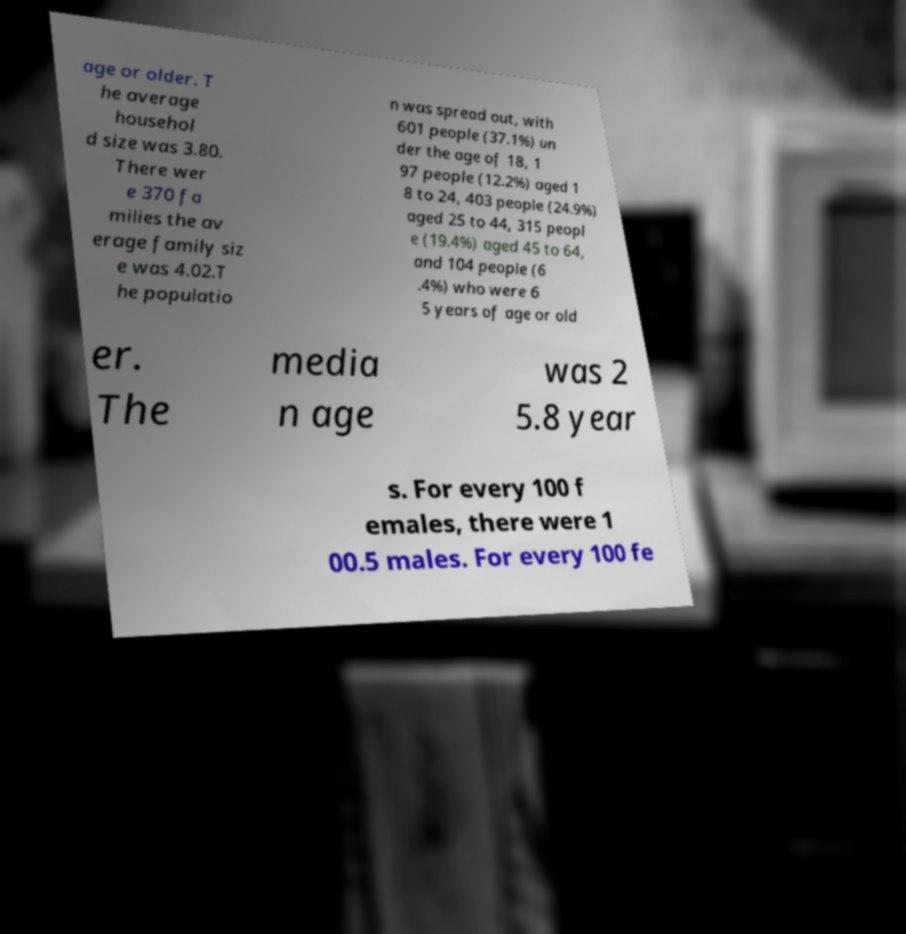Could you assist in decoding the text presented in this image and type it out clearly? age or older. T he average househol d size was 3.80. There wer e 370 fa milies the av erage family siz e was 4.02.T he populatio n was spread out, with 601 people (37.1%) un der the age of 18, 1 97 people (12.2%) aged 1 8 to 24, 403 people (24.9%) aged 25 to 44, 315 peopl e (19.4%) aged 45 to 64, and 104 people (6 .4%) who were 6 5 years of age or old er. The media n age was 2 5.8 year s. For every 100 f emales, there were 1 00.5 males. For every 100 fe 